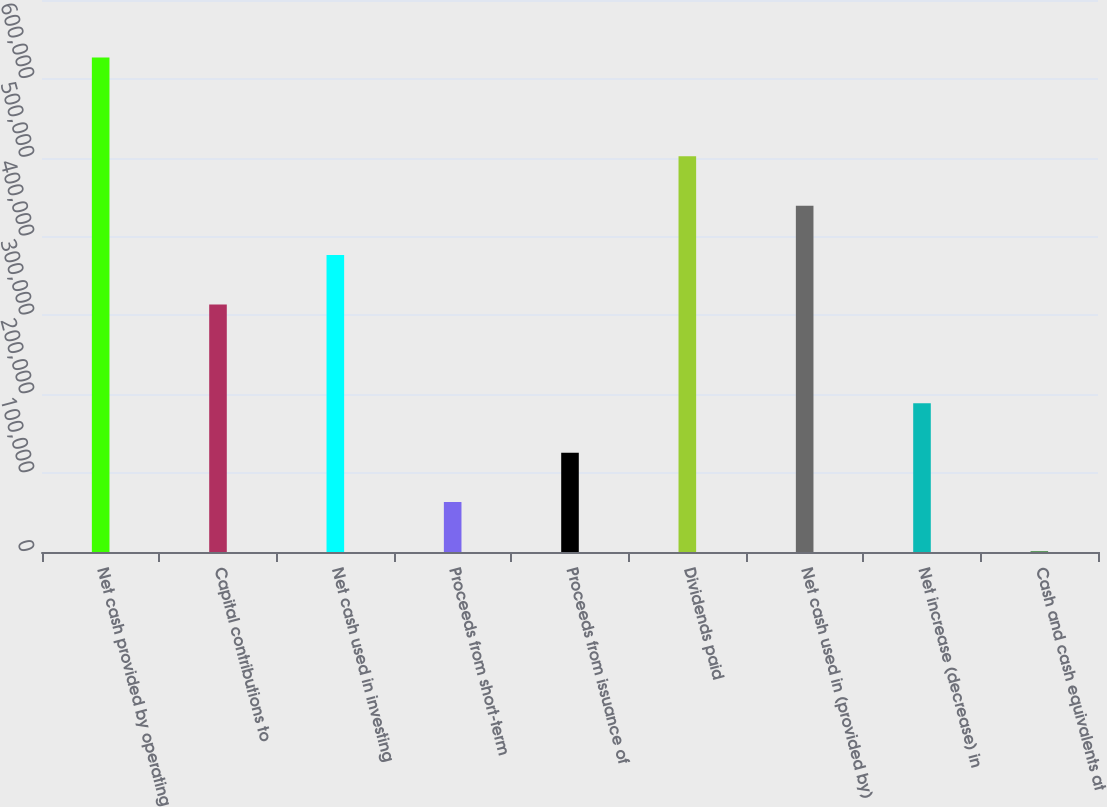Convert chart. <chart><loc_0><loc_0><loc_500><loc_500><bar_chart><fcel>Net cash provided by operating<fcel>Capital contributions to<fcel>Net cash used in investing<fcel>Proceeds from short-term<fcel>Proceeds from issuance of<fcel>Dividends paid<fcel>Net cash used in (provided by)<fcel>Net increase (decrease) in<fcel>Cash and cash equivalents at<nl><fcel>627013<fcel>313880<fcel>376507<fcel>63374.5<fcel>126001<fcel>501760<fcel>439134<fcel>188628<fcel>748<nl></chart> 